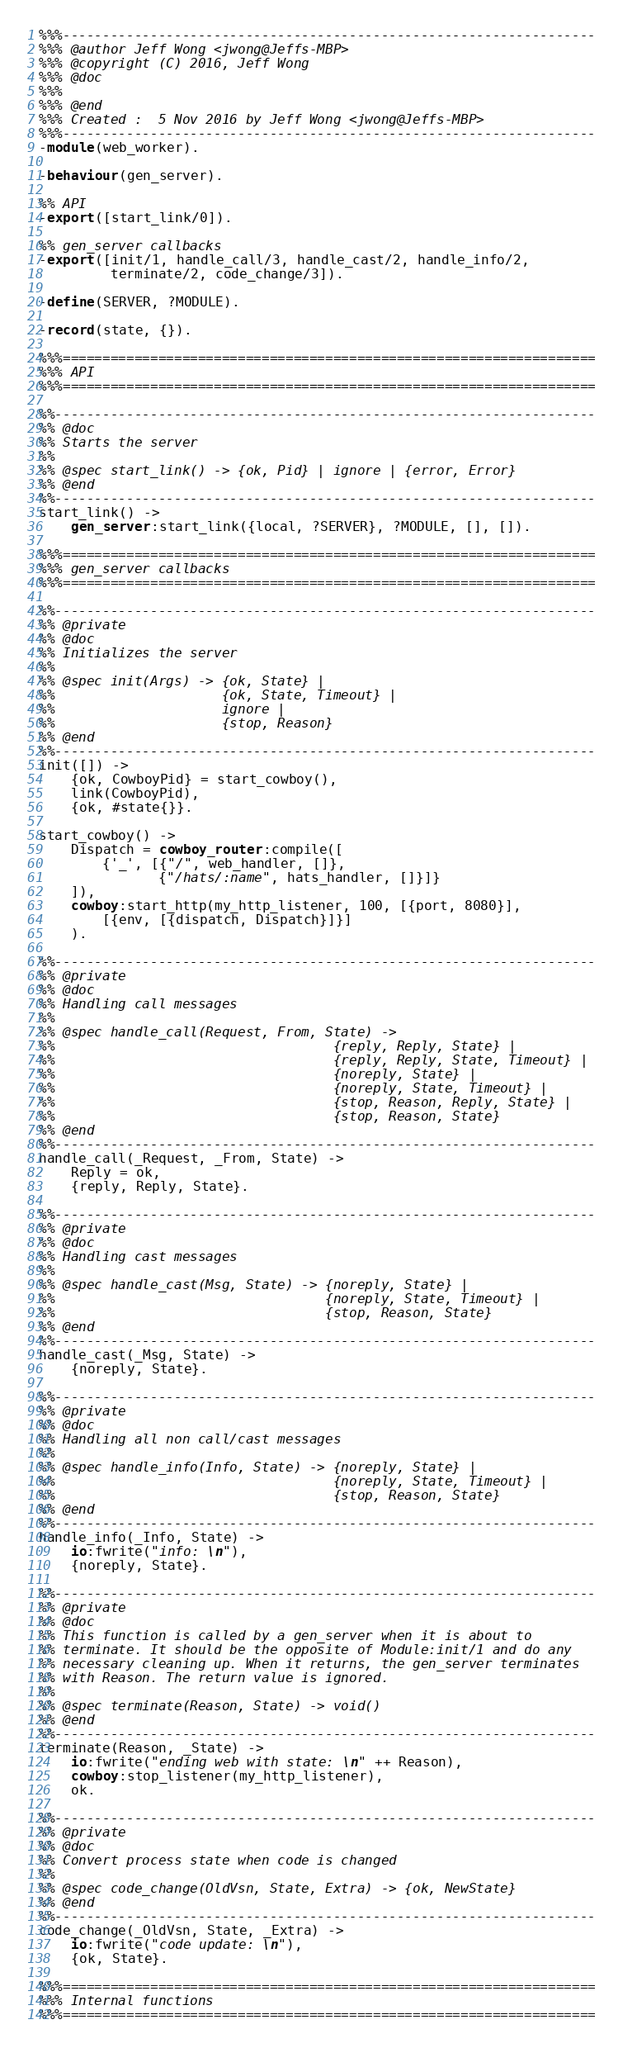<code> <loc_0><loc_0><loc_500><loc_500><_Erlang_>%%%-------------------------------------------------------------------
%%% @author Jeff Wong <jwong@Jeffs-MBP>
%%% @copyright (C) 2016, Jeff Wong
%%% @doc
%%%
%%% @end
%%% Created :  5 Nov 2016 by Jeff Wong <jwong@Jeffs-MBP>
%%%-------------------------------------------------------------------
-module(web_worker).

-behaviour(gen_server).

%% API
-export([start_link/0]).

%% gen_server callbacks
-export([init/1, handle_call/3, handle_cast/2, handle_info/2,
         terminate/2, code_change/3]).

-define(SERVER, ?MODULE).

-record(state, {}).

%%%===================================================================
%%% API
%%%===================================================================

%%--------------------------------------------------------------------
%% @doc
%% Starts the server
%%
%% @spec start_link() -> {ok, Pid} | ignore | {error, Error}
%% @end
%%--------------------------------------------------------------------
start_link() ->
    gen_server:start_link({local, ?SERVER}, ?MODULE, [], []).

%%%===================================================================
%%% gen_server callbacks
%%%===================================================================

%%--------------------------------------------------------------------
%% @private
%% @doc
%% Initializes the server
%%
%% @spec init(Args) -> {ok, State} |
%%                     {ok, State, Timeout} |
%%                     ignore |
%%                     {stop, Reason}
%% @end
%%--------------------------------------------------------------------
init([]) ->
    {ok, CowboyPid} = start_cowboy(),
    link(CowboyPid),
    {ok, #state{}}.

start_cowboy() ->
    Dispatch = cowboy_router:compile([
        {'_', [{"/", web_handler, []},
               {"/hats/:name", hats_handler, []}]}
    ]),
    cowboy:start_http(my_http_listener, 100, [{port, 8080}],
        [{env, [{dispatch, Dispatch}]}]
    ).

%%--------------------------------------------------------------------
%% @private
%% @doc
%% Handling call messages
%%
%% @spec handle_call(Request, From, State) ->
%%                                   {reply, Reply, State} |
%%                                   {reply, Reply, State, Timeout} |
%%                                   {noreply, State} |
%%                                   {noreply, State, Timeout} |
%%                                   {stop, Reason, Reply, State} |
%%                                   {stop, Reason, State}
%% @end
%%--------------------------------------------------------------------
handle_call(_Request, _From, State) ->
    Reply = ok,
    {reply, Reply, State}.

%%--------------------------------------------------------------------
%% @private
%% @doc
%% Handling cast messages
%%
%% @spec handle_cast(Msg, State) -> {noreply, State} |
%%                                  {noreply, State, Timeout} |
%%                                  {stop, Reason, State}
%% @end
%%--------------------------------------------------------------------
handle_cast(_Msg, State) ->
    {noreply, State}.

%%--------------------------------------------------------------------
%% @private
%% @doc
%% Handling all non call/cast messages
%%
%% @spec handle_info(Info, State) -> {noreply, State} |
%%                                   {noreply, State, Timeout} |
%%                                   {stop, Reason, State}
%% @end
%%--------------------------------------------------------------------
handle_info(_Info, State) ->
    io:fwrite("info: \n"),
    {noreply, State}.

%%--------------------------------------------------------------------
%% @private
%% @doc
%% This function is called by a gen_server when it is about to
%% terminate. It should be the opposite of Module:init/1 and do any
%% necessary cleaning up. When it returns, the gen_server terminates
%% with Reason. The return value is ignored.
%%
%% @spec terminate(Reason, State) -> void()
%% @end
%%--------------------------------------------------------------------
terminate(Reason, _State) ->
    io:fwrite("ending web with state: \n" ++ Reason),
    cowboy:stop_listener(my_http_listener),
    ok.

%%--------------------------------------------------------------------
%% @private
%% @doc
%% Convert process state when code is changed
%%
%% @spec code_change(OldVsn, State, Extra) -> {ok, NewState}
%% @end
%%--------------------------------------------------------------------
code_change(_OldVsn, State, _Extra) ->
    io:fwrite("code update: \n"),
    {ok, State}.

%%%===================================================================
%%% Internal functions
%%%===================================================================
</code> 